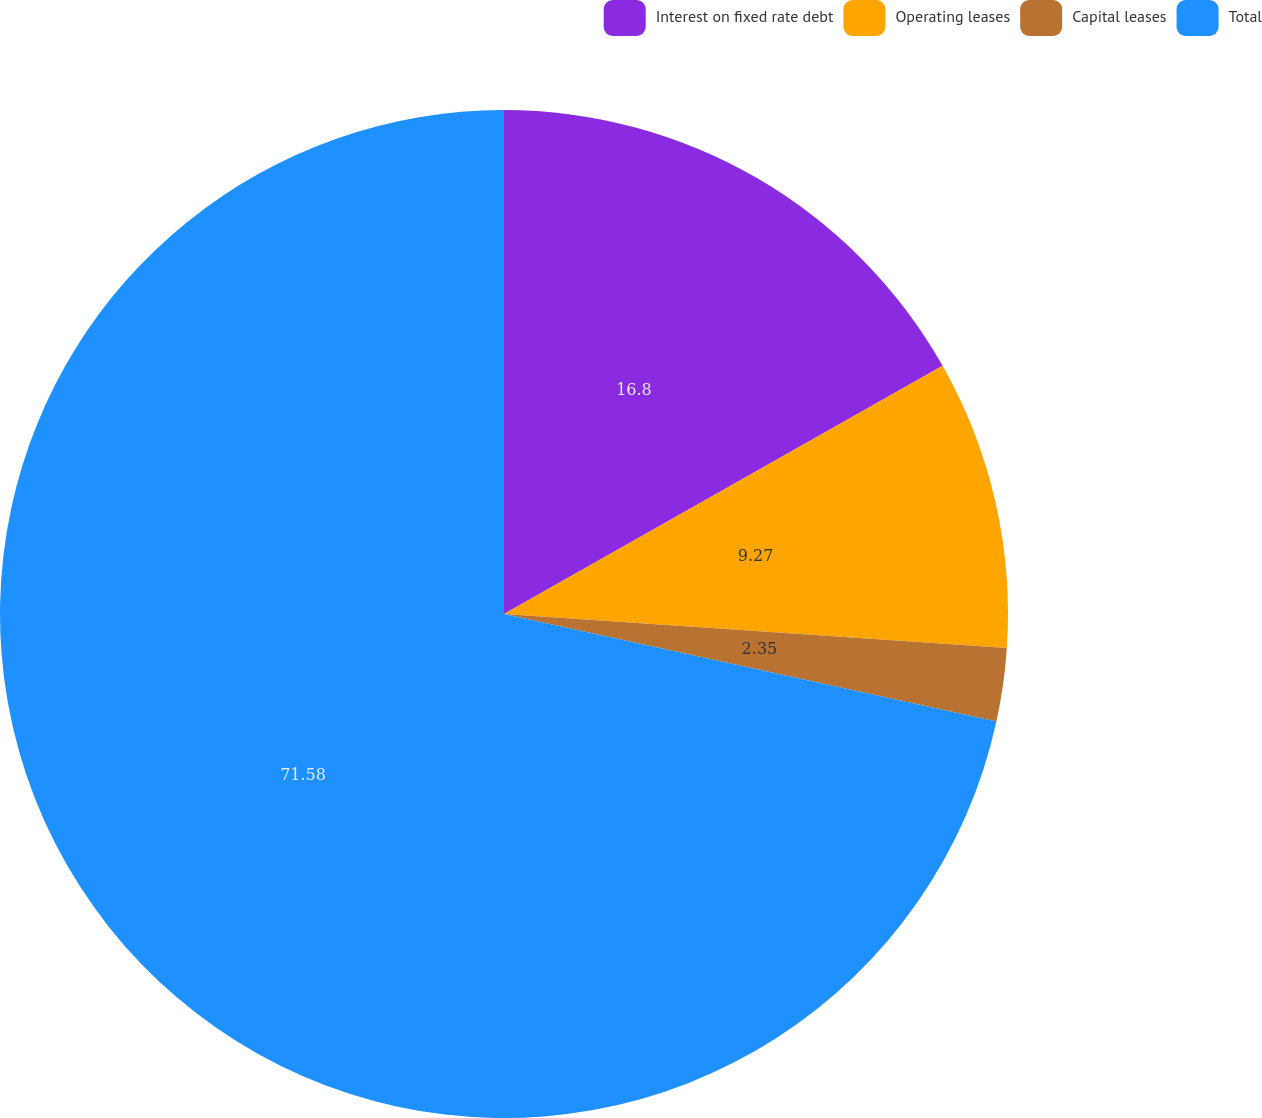Convert chart. <chart><loc_0><loc_0><loc_500><loc_500><pie_chart><fcel>Interest on fixed rate debt<fcel>Operating leases<fcel>Capital leases<fcel>Total<nl><fcel>16.8%<fcel>9.27%<fcel>2.35%<fcel>71.57%<nl></chart> 